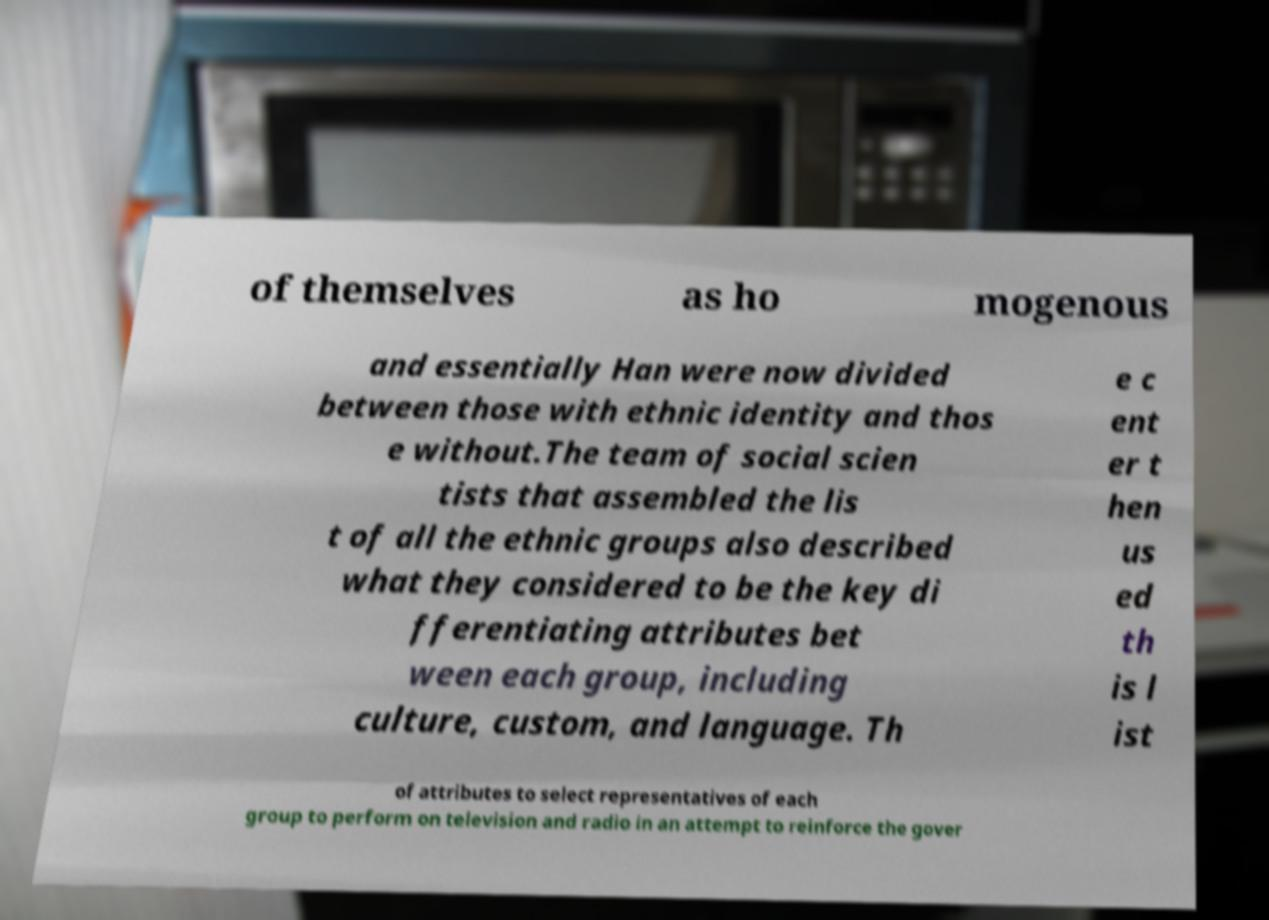Could you extract and type out the text from this image? of themselves as ho mogenous and essentially Han were now divided between those with ethnic identity and thos e without.The team of social scien tists that assembled the lis t of all the ethnic groups also described what they considered to be the key di fferentiating attributes bet ween each group, including culture, custom, and language. Th e c ent er t hen us ed th is l ist of attributes to select representatives of each group to perform on television and radio in an attempt to reinforce the gover 